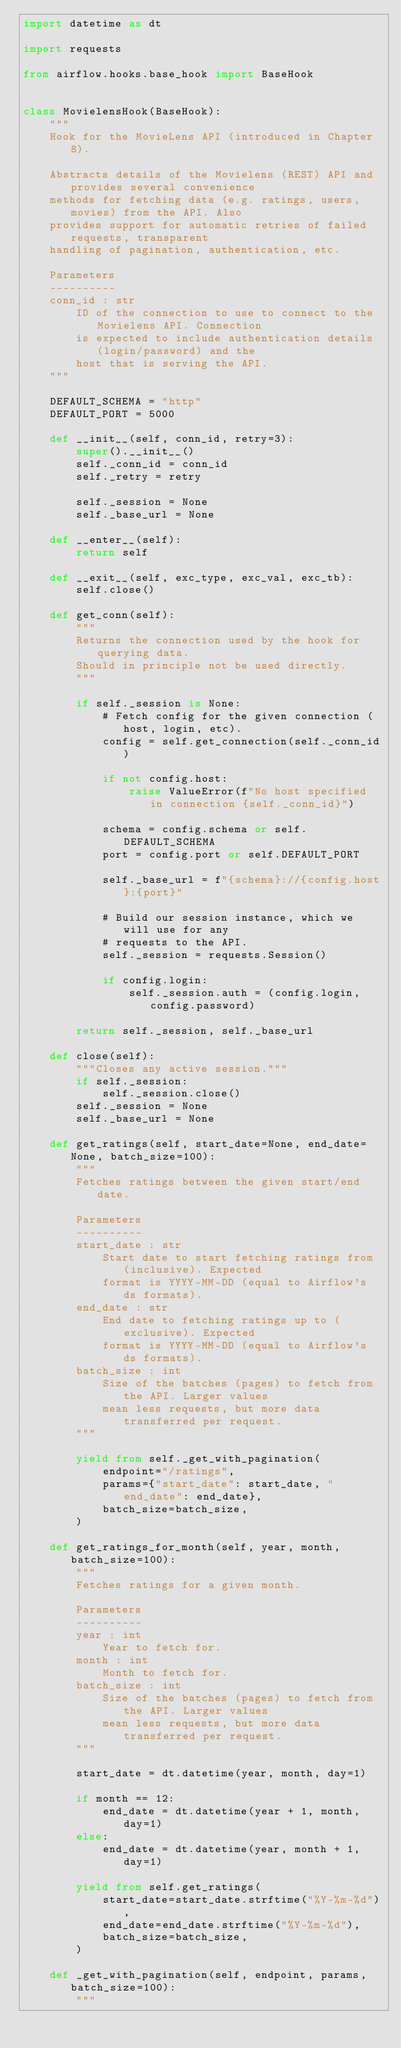<code> <loc_0><loc_0><loc_500><loc_500><_Python_>import datetime as dt

import requests

from airflow.hooks.base_hook import BaseHook


class MovielensHook(BaseHook):
    """
    Hook for the MovieLens API (introduced in Chapter 8).

    Abstracts details of the Movielens (REST) API and provides several convenience
    methods for fetching data (e.g. ratings, users, movies) from the API. Also
    provides support for automatic retries of failed requests, transparent
    handling of pagination, authentication, etc.

    Parameters
    ----------
    conn_id : str
        ID of the connection to use to connect to the Movielens API. Connection
        is expected to include authentication details (login/password) and the
        host that is serving the API.
    """

    DEFAULT_SCHEMA = "http"
    DEFAULT_PORT = 5000

    def __init__(self, conn_id, retry=3):
        super().__init__()
        self._conn_id = conn_id
        self._retry = retry

        self._session = None
        self._base_url = None

    def __enter__(self):
        return self

    def __exit__(self, exc_type, exc_val, exc_tb):
        self.close()

    def get_conn(self):
        """
        Returns the connection used by the hook for querying data.
        Should in principle not be used directly.
        """

        if self._session is None:
            # Fetch config for the given connection (host, login, etc).
            config = self.get_connection(self._conn_id)

            if not config.host:
                raise ValueError(f"No host specified in connection {self._conn_id}")

            schema = config.schema or self.DEFAULT_SCHEMA
            port = config.port or self.DEFAULT_PORT

            self._base_url = f"{schema}://{config.host}:{port}"

            # Build our session instance, which we will use for any
            # requests to the API.
            self._session = requests.Session()

            if config.login:
                self._session.auth = (config.login, config.password)

        return self._session, self._base_url

    def close(self):
        """Closes any active session."""
        if self._session:
            self._session.close()
        self._session = None
        self._base_url = None

    def get_ratings(self, start_date=None, end_date=None, batch_size=100):
        """
        Fetches ratings between the given start/end date.

        Parameters
        ----------
        start_date : str
            Start date to start fetching ratings from (inclusive). Expected
            format is YYYY-MM-DD (equal to Airflow's ds formats).
        end_date : str
            End date to fetching ratings up to (exclusive). Expected
            format is YYYY-MM-DD (equal to Airflow's ds formats).
        batch_size : int
            Size of the batches (pages) to fetch from the API. Larger values
            mean less requests, but more data transferred per request.
        """

        yield from self._get_with_pagination(
            endpoint="/ratings",
            params={"start_date": start_date, "end_date": end_date},
            batch_size=batch_size,
        )

    def get_ratings_for_month(self, year, month, batch_size=100):
        """
        Fetches ratings for a given month.

        Parameters
        ----------
        year : int
            Year to fetch for.
        month : int
            Month to fetch for.
        batch_size : int
            Size of the batches (pages) to fetch from the API. Larger values
            mean less requests, but more data transferred per request.
        """

        start_date = dt.datetime(year, month, day=1)

        if month == 12:
            end_date = dt.datetime(year + 1, month, day=1)
        else:
            end_date = dt.datetime(year, month + 1, day=1)

        yield from self.get_ratings(
            start_date=start_date.strftime("%Y-%m-%d"),
            end_date=end_date.strftime("%Y-%m-%d"),
            batch_size=batch_size,
        )

    def _get_with_pagination(self, endpoint, params, batch_size=100):
        """</code> 